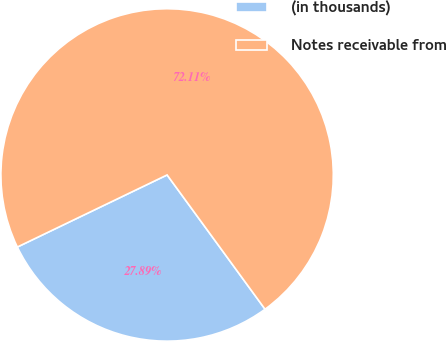<chart> <loc_0><loc_0><loc_500><loc_500><pie_chart><fcel>(in thousands)<fcel>Notes receivable from<nl><fcel>27.89%<fcel>72.11%<nl></chart> 